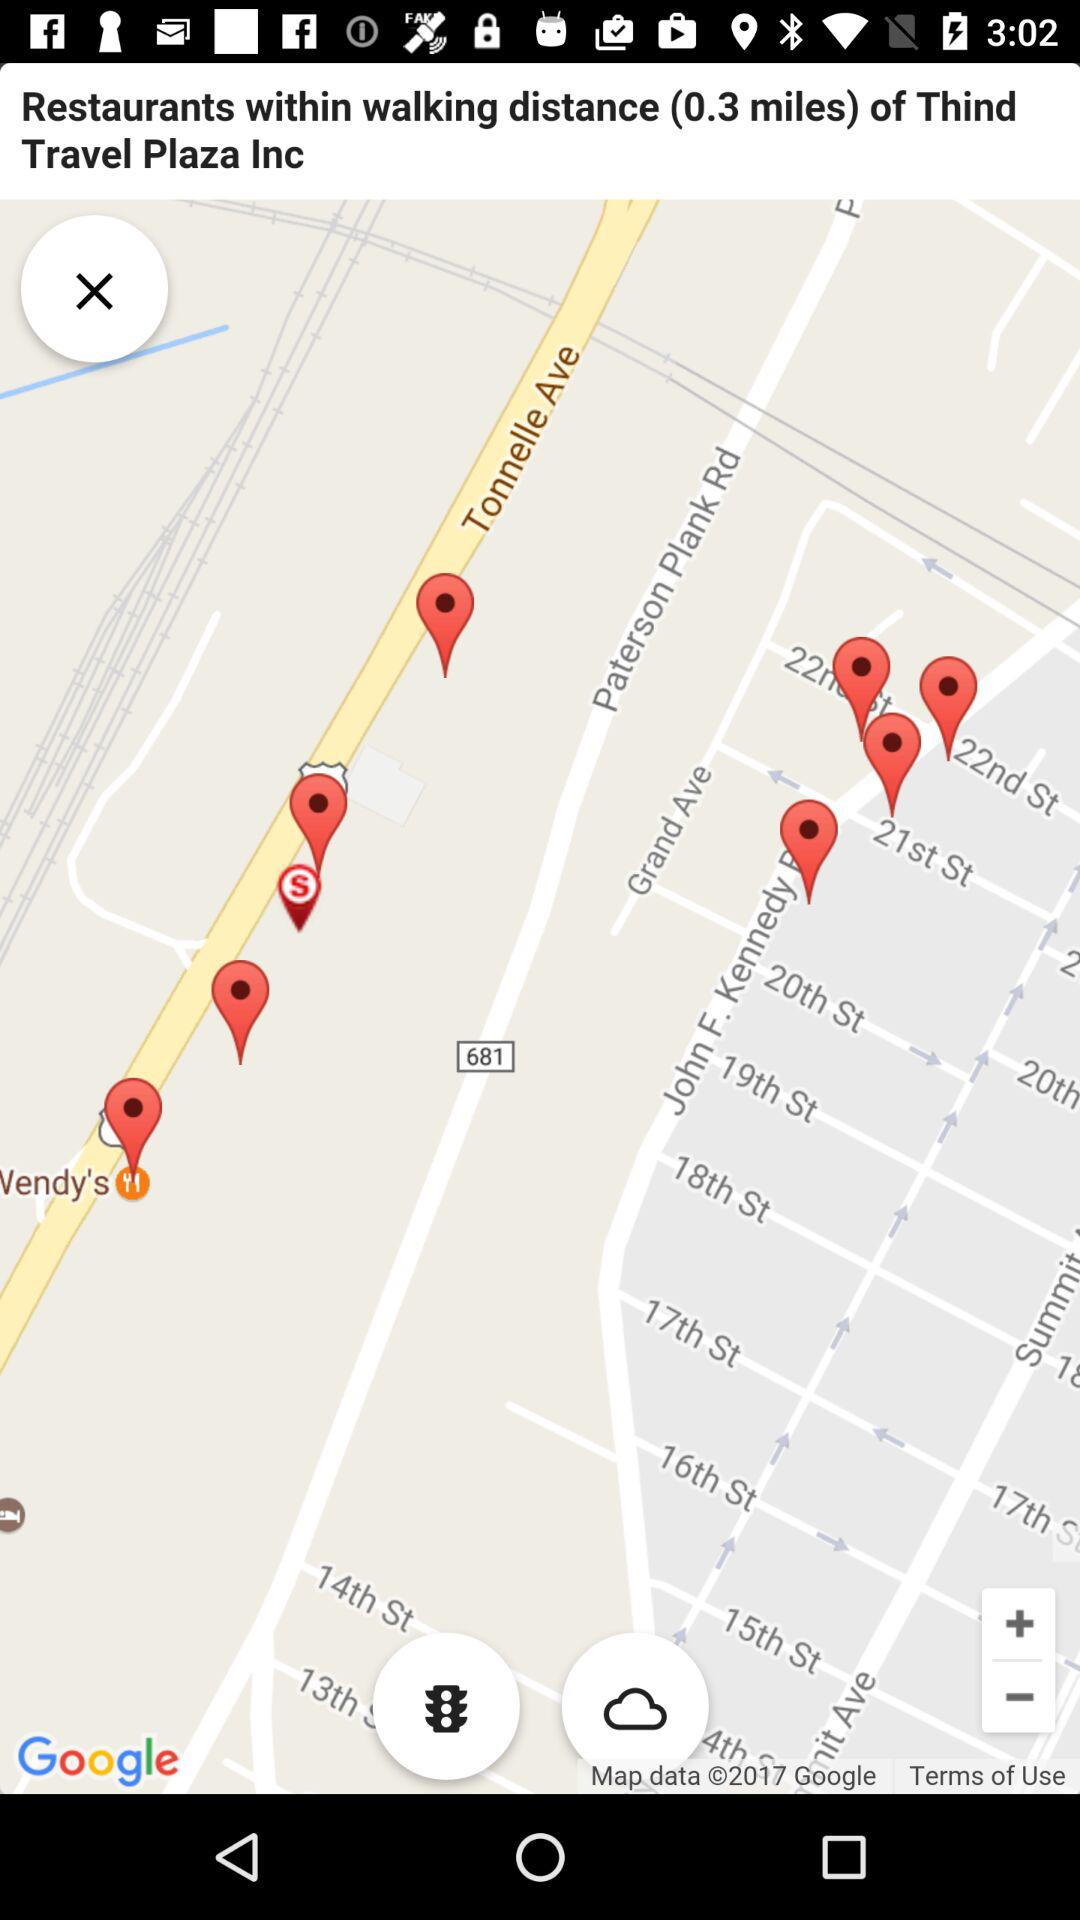What is the distance from the user to the restaurants?
Answer the question using a single word or phrase. 0.3 miles 